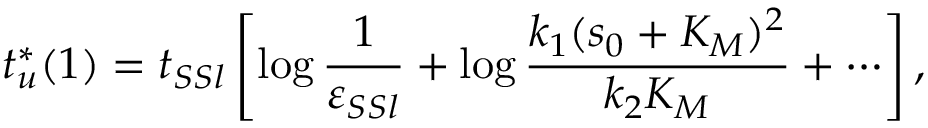<formula> <loc_0><loc_0><loc_500><loc_500>t _ { u } ^ { * } ( 1 ) = t _ { S S l } \left [ \log \frac { 1 } { \varepsilon _ { S S l } } + \log \frac { k _ { 1 } ( s _ { 0 } + K _ { M } ) ^ { 2 } } { k _ { 2 } K _ { M } } + \cdots \right ] ,</formula> 